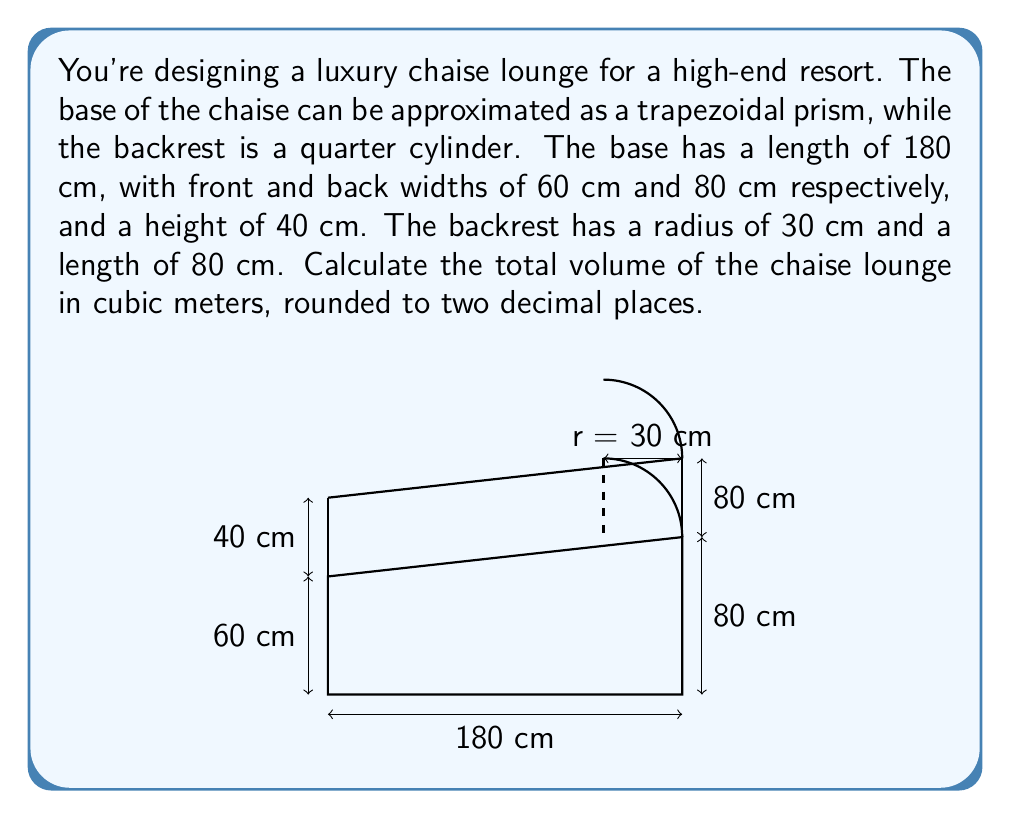Can you solve this math problem? Let's break this problem into two parts: calculating the volume of the base and the volume of the backrest.

1. Volume of the base (trapezoidal prism):
   The formula for the volume of a trapezoidal prism is:
   $$V_{base} = \frac{1}{2}(a+b)hL$$
   where $a$ and $b$ are the parallel sides, $h$ is the height between them, and $L$ is the length.

   Substituting the values:
   $$V_{base} = \frac{1}{2}(60+80) \times 40 \times 180 = 504,000 \text{ cm}^3$$

2. Volume of the backrest (quarter cylinder):
   The formula for the volume of a cylinder is $V = \pi r^2 h$, but we only need a quarter of this:
   $$V_{backrest} = \frac{1}{4} \pi r^2 L$$

   Substituting the values:
   $$V_{backrest} = \frac{1}{4} \pi \times 30^2 \times 80 = 56,548.67 \text{ cm}^3$$

3. Total volume:
   $$V_{total} = V_{base} + V_{backrest} = 504,000 + 56,548.67 = 560,548.67 \text{ cm}^3$$

4. Converting to cubic meters and rounding:
   $$560,548.67 \text{ cm}^3 = 0.56054867 \text{ m}^3 \approx 0.56 \text{ m}^3$$
Answer: $0.56 \text{ m}^3$ 